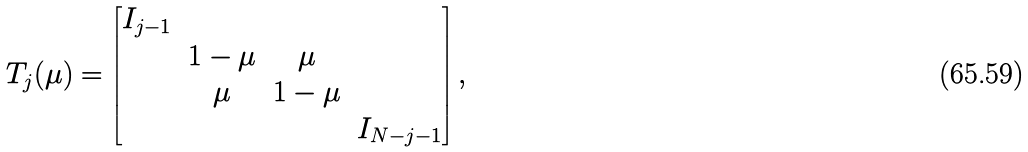<formula> <loc_0><loc_0><loc_500><loc_500>T _ { j } ( \mu ) = \begin{bmatrix} I _ { j - 1 } & & & \\ & 1 - \mu & \mu & \\ & \mu & 1 - \mu & \\ & & & I _ { N - j - 1 } \end{bmatrix} ,</formula> 